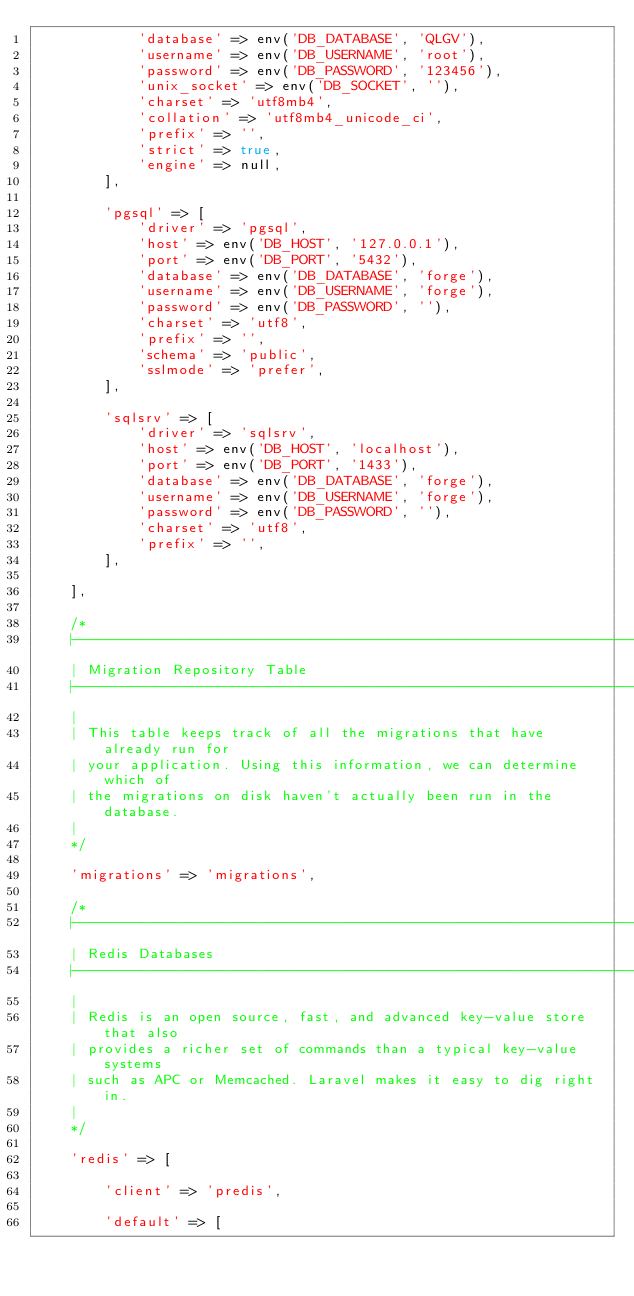<code> <loc_0><loc_0><loc_500><loc_500><_PHP_>            'database' => env('DB_DATABASE', 'QLGV'),
            'username' => env('DB_USERNAME', 'root'),
            'password' => env('DB_PASSWORD', '123456'),
            'unix_socket' => env('DB_SOCKET', ''),
            'charset' => 'utf8mb4',
            'collation' => 'utf8mb4_unicode_ci',
            'prefix' => '',
            'strict' => true,
            'engine' => null,
        ],

        'pgsql' => [
            'driver' => 'pgsql',
            'host' => env('DB_HOST', '127.0.0.1'),
            'port' => env('DB_PORT', '5432'),
            'database' => env('DB_DATABASE', 'forge'),
            'username' => env('DB_USERNAME', 'forge'),
            'password' => env('DB_PASSWORD', ''),
            'charset' => 'utf8',
            'prefix' => '',
            'schema' => 'public',
            'sslmode' => 'prefer',
        ],

        'sqlsrv' => [
            'driver' => 'sqlsrv',
            'host' => env('DB_HOST', 'localhost'),
            'port' => env('DB_PORT', '1433'),
            'database' => env('DB_DATABASE', 'forge'),
            'username' => env('DB_USERNAME', 'forge'),
            'password' => env('DB_PASSWORD', ''),
            'charset' => 'utf8',
            'prefix' => '',
        ],

    ],

    /*
    |--------------------------------------------------------------------------
    | Migration Repository Table
    |--------------------------------------------------------------------------
    |
    | This table keeps track of all the migrations that have already run for
    | your application. Using this information, we can determine which of
    | the migrations on disk haven't actually been run in the database.
    |
    */

    'migrations' => 'migrations',

    /*
    |--------------------------------------------------------------------------
    | Redis Databases
    |--------------------------------------------------------------------------
    |
    | Redis is an open source, fast, and advanced key-value store that also
    | provides a richer set of commands than a typical key-value systems
    | such as APC or Memcached. Laravel makes it easy to dig right in.
    |
    */

    'redis' => [

        'client' => 'predis',

        'default' => [</code> 